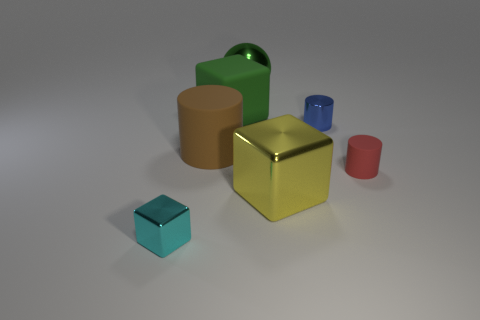Is the material of the large object to the right of the large green ball the same as the big green block?
Keep it short and to the point. No. Is there any other thing that has the same material as the big green ball?
Your answer should be compact. Yes. How many large rubber things are in front of the small metal thing that is to the left of the tiny metallic object that is to the right of the yellow cube?
Your answer should be very brief. 0. There is a tiny metallic object that is to the right of the large metallic block; does it have the same shape as the brown rubber thing?
Give a very brief answer. Yes. How many things are either big brown spheres or large cubes that are behind the small shiny cylinder?
Provide a short and direct response. 1. Is the number of matte cylinders right of the tiny red matte object greater than the number of brown cylinders?
Your answer should be compact. No. Is the number of large green rubber things to the right of the large yellow metal thing the same as the number of small rubber cylinders on the left side of the green rubber thing?
Provide a succinct answer. Yes. Are there any big metal spheres to the right of the shiny cube to the right of the cyan object?
Your answer should be compact. No. What shape is the tiny cyan metallic thing?
Ensure brevity in your answer.  Cube. What is the size of the ball that is the same color as the big rubber cube?
Make the answer very short. Large. 